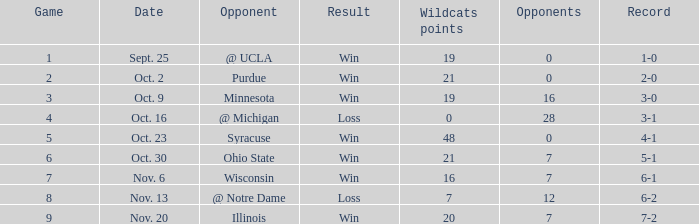What is the lowest points scored by the Wildcats when the record was 5-1? 21.0. 